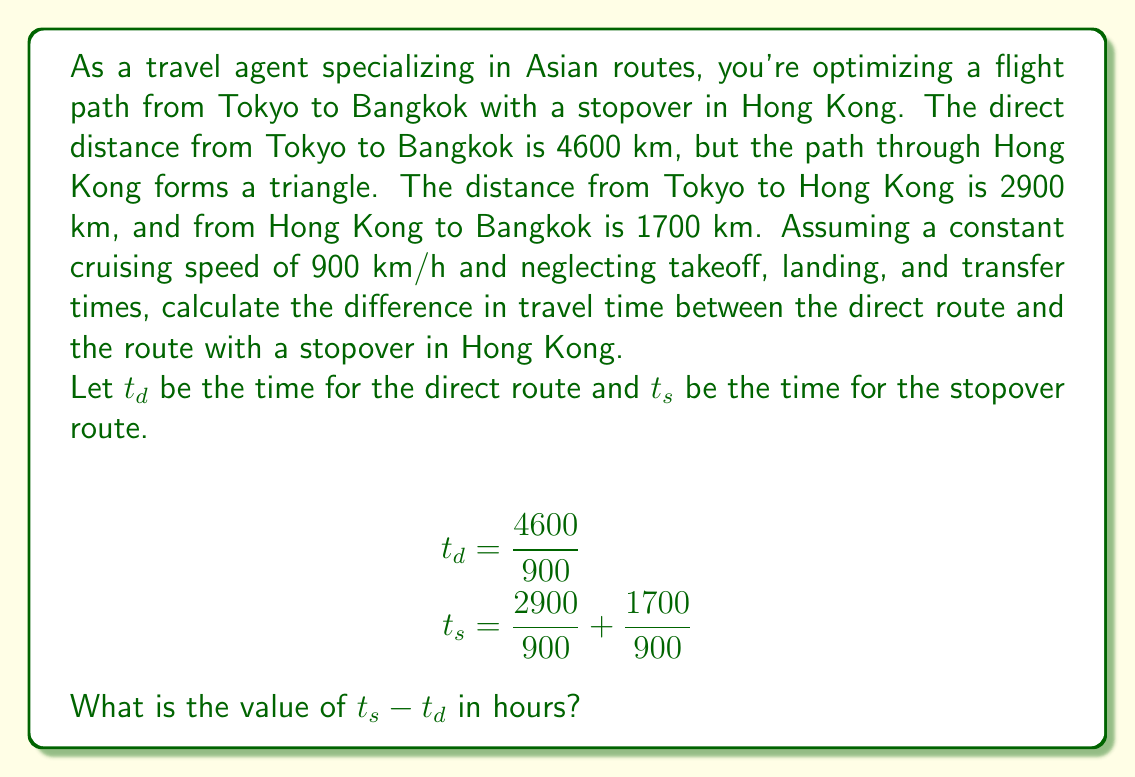What is the answer to this math problem? To solve this problem, we need to calculate the travel time for both routes and then find the difference.

1. Direct route time ($t_d$):
   $$t_d = \frac{4600 \text{ km}}{900 \text{ km/h}} = \frac{46}{9} \text{ hours} \approx 5.11 \text{ hours}$$

2. Stopover route time ($t_s$):
   $$t_s = \frac{2900 \text{ km}}{900 \text{ km/h}} + \frac{1700 \text{ km}}{900 \text{ km/h}}$$
   $$t_s = \frac{2900 + 1700}{900} \text{ hours} = \frac{4600}{900} \text{ hours} = \frac{46}{9} \text{ hours} \approx 5.11 \text{ hours}$$

3. Difference in travel time:
   $$t_s - t_d = \frac{46}{9} - \frac{46}{9} = 0 \text{ hours}$$

Interestingly, in this case, the travel time for both routes is exactly the same. This is because the total distance traveled in both cases is 4600 km, and we're assuming a constant cruising speed without considering other factors like takeoff, landing, and transfer times.

In reality, the stopover route would take longer due to these additional factors, but purely based on distance and constant speed, there is no difference in travel time.
Answer: 0 hours 